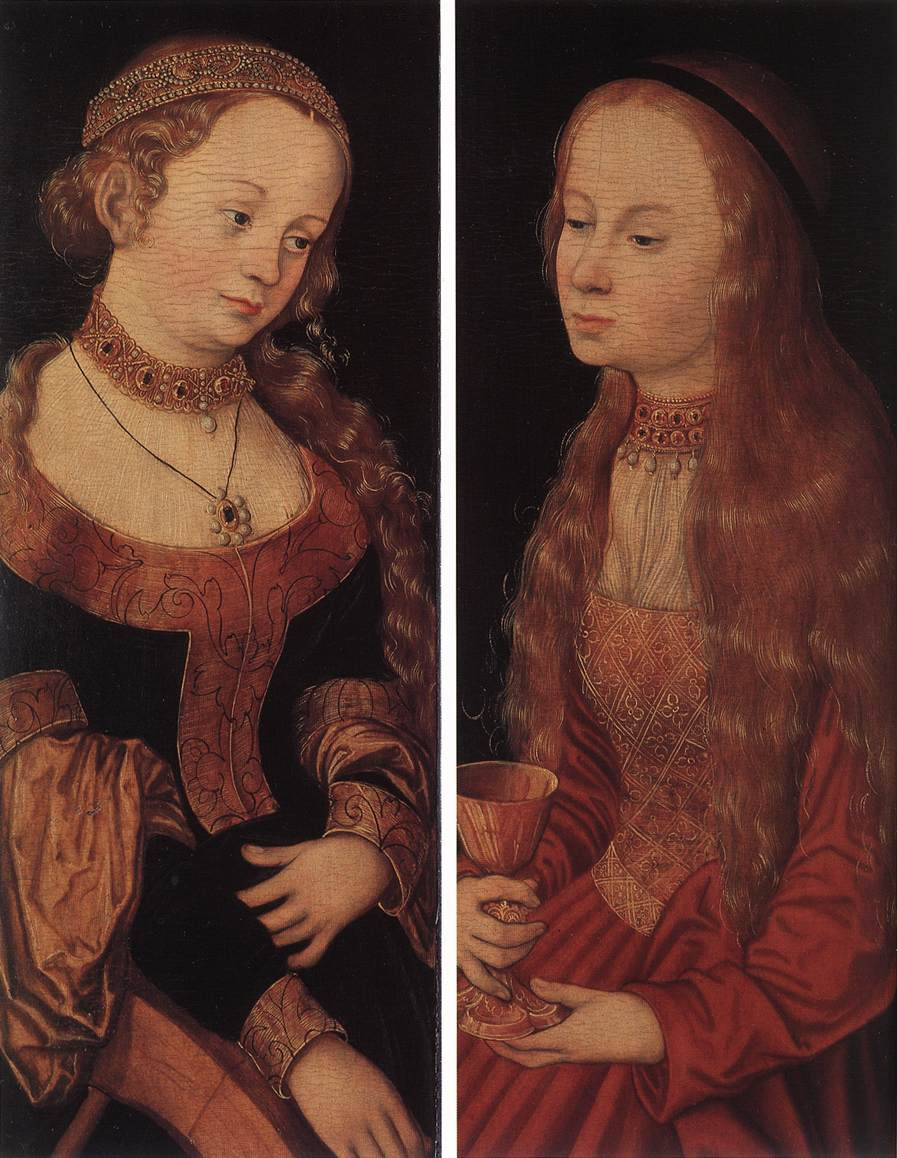Who are the possible historical figures these women might represent? While it's speculative, these women could represent archetypal figures or even be portraits of contemporary women of the time, possibly patrons or muses of the artist. If they were to symbolize virtues, the woman with the book might represent wisdom or learning, while the one with the cup could symbolize generosity or faith. Given the Northern Renaissance's focus on detailed symbolism, these figures might also be saintly representations or allegories of certain human attributes.  Imagine these women come to life - what kind of conversation might they have? Blonde Woman: 'Sister, have you pondered over the teachings in this book? It speaks of wisdom that transcends our time, interwoven with the beauty of the natural world as delicate as this flower I hold.'

Red-Haired Woman: 'Indeed, dear sister. Yet, I find solace in this chalice, a vessel of abundance and mystery. It holds not just earthly sustenance but also the essence of divine grace. Perhaps, our paths to understanding are different, but together they form a tapestry of enlightenment.'

Blonde Woman: 'True. The blending of our individual symbols might unlock a greater truth, one that is depicted in the intricate threads of our very garments. Knowledge and receptivity – two sides of the sharegpt4v/same coin in our quest for deeper insight.'

Red-Haired Woman: 'And in this solemn stillness, we remain guardians of these truths, captured in the eternal brushstrokes of a master artist.' 